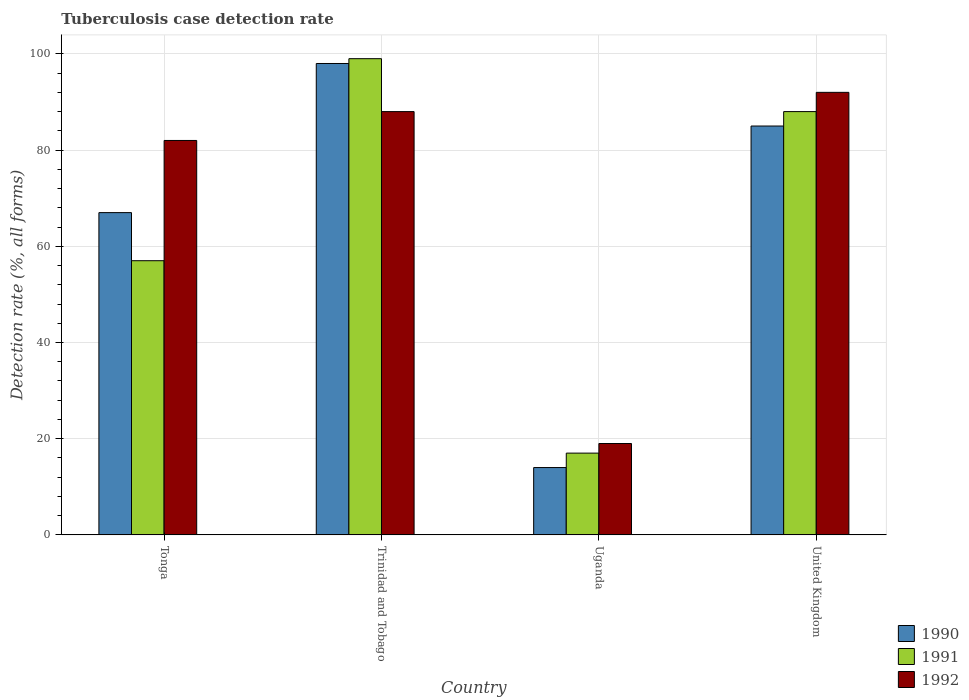How many different coloured bars are there?
Offer a very short reply. 3. Are the number of bars on each tick of the X-axis equal?
Your answer should be compact. Yes. How many bars are there on the 1st tick from the left?
Your answer should be compact. 3. What is the label of the 3rd group of bars from the left?
Offer a very short reply. Uganda. In how many cases, is the number of bars for a given country not equal to the number of legend labels?
Offer a terse response. 0. In which country was the tuberculosis case detection rate in in 1991 maximum?
Give a very brief answer. Trinidad and Tobago. In which country was the tuberculosis case detection rate in in 1991 minimum?
Give a very brief answer. Uganda. What is the total tuberculosis case detection rate in in 1990 in the graph?
Give a very brief answer. 264. What is the difference between the tuberculosis case detection rate in in 1990 in Uganda and that in United Kingdom?
Provide a succinct answer. -71. What is the difference between the tuberculosis case detection rate in in 1992 in Trinidad and Tobago and the tuberculosis case detection rate in in 1991 in Uganda?
Offer a very short reply. 71. What is the average tuberculosis case detection rate in in 1991 per country?
Offer a terse response. 65.25. What is the difference between the tuberculosis case detection rate in of/in 1992 and tuberculosis case detection rate in of/in 1990 in Uganda?
Offer a terse response. 5. What is the ratio of the tuberculosis case detection rate in in 1991 in Tonga to that in Trinidad and Tobago?
Your answer should be very brief. 0.58. Is the tuberculosis case detection rate in in 1991 in Tonga less than that in Trinidad and Tobago?
Provide a succinct answer. Yes. Is the difference between the tuberculosis case detection rate in in 1992 in Uganda and United Kingdom greater than the difference between the tuberculosis case detection rate in in 1990 in Uganda and United Kingdom?
Ensure brevity in your answer.  No. What does the 1st bar from the left in Tonga represents?
Provide a short and direct response. 1990. Is it the case that in every country, the sum of the tuberculosis case detection rate in in 1990 and tuberculosis case detection rate in in 1992 is greater than the tuberculosis case detection rate in in 1991?
Your answer should be compact. Yes. How many bars are there?
Offer a very short reply. 12. Are all the bars in the graph horizontal?
Offer a very short reply. No. Does the graph contain grids?
Your response must be concise. Yes. What is the title of the graph?
Your response must be concise. Tuberculosis case detection rate. What is the label or title of the Y-axis?
Your response must be concise. Detection rate (%, all forms). What is the Detection rate (%, all forms) in 1990 in Tonga?
Make the answer very short. 67. What is the Detection rate (%, all forms) of 1992 in Tonga?
Give a very brief answer. 82. What is the Detection rate (%, all forms) in 1991 in Trinidad and Tobago?
Your answer should be compact. 99. What is the Detection rate (%, all forms) of 1992 in Trinidad and Tobago?
Provide a short and direct response. 88. What is the Detection rate (%, all forms) of 1992 in United Kingdom?
Provide a short and direct response. 92. Across all countries, what is the maximum Detection rate (%, all forms) in 1992?
Your answer should be very brief. 92. What is the total Detection rate (%, all forms) of 1990 in the graph?
Your response must be concise. 264. What is the total Detection rate (%, all forms) in 1991 in the graph?
Make the answer very short. 261. What is the total Detection rate (%, all forms) of 1992 in the graph?
Your answer should be very brief. 281. What is the difference between the Detection rate (%, all forms) in 1990 in Tonga and that in Trinidad and Tobago?
Offer a terse response. -31. What is the difference between the Detection rate (%, all forms) in 1991 in Tonga and that in Trinidad and Tobago?
Provide a short and direct response. -42. What is the difference between the Detection rate (%, all forms) of 1991 in Tonga and that in Uganda?
Your answer should be compact. 40. What is the difference between the Detection rate (%, all forms) in 1990 in Tonga and that in United Kingdom?
Offer a terse response. -18. What is the difference between the Detection rate (%, all forms) of 1991 in Tonga and that in United Kingdom?
Your answer should be compact. -31. What is the difference between the Detection rate (%, all forms) in 1992 in Trinidad and Tobago and that in Uganda?
Make the answer very short. 69. What is the difference between the Detection rate (%, all forms) in 1992 in Trinidad and Tobago and that in United Kingdom?
Your answer should be compact. -4. What is the difference between the Detection rate (%, all forms) of 1990 in Uganda and that in United Kingdom?
Ensure brevity in your answer.  -71. What is the difference between the Detection rate (%, all forms) of 1991 in Uganda and that in United Kingdom?
Your response must be concise. -71. What is the difference between the Detection rate (%, all forms) of 1992 in Uganda and that in United Kingdom?
Make the answer very short. -73. What is the difference between the Detection rate (%, all forms) of 1990 in Tonga and the Detection rate (%, all forms) of 1991 in Trinidad and Tobago?
Give a very brief answer. -32. What is the difference between the Detection rate (%, all forms) in 1990 in Tonga and the Detection rate (%, all forms) in 1992 in Trinidad and Tobago?
Provide a short and direct response. -21. What is the difference between the Detection rate (%, all forms) of 1991 in Tonga and the Detection rate (%, all forms) of 1992 in Trinidad and Tobago?
Your response must be concise. -31. What is the difference between the Detection rate (%, all forms) in 1990 in Tonga and the Detection rate (%, all forms) in 1991 in Uganda?
Ensure brevity in your answer.  50. What is the difference between the Detection rate (%, all forms) of 1990 in Tonga and the Detection rate (%, all forms) of 1992 in Uganda?
Keep it short and to the point. 48. What is the difference between the Detection rate (%, all forms) of 1991 in Tonga and the Detection rate (%, all forms) of 1992 in Uganda?
Make the answer very short. 38. What is the difference between the Detection rate (%, all forms) of 1990 in Tonga and the Detection rate (%, all forms) of 1992 in United Kingdom?
Give a very brief answer. -25. What is the difference between the Detection rate (%, all forms) of 1991 in Tonga and the Detection rate (%, all forms) of 1992 in United Kingdom?
Ensure brevity in your answer.  -35. What is the difference between the Detection rate (%, all forms) of 1990 in Trinidad and Tobago and the Detection rate (%, all forms) of 1992 in Uganda?
Your answer should be very brief. 79. What is the difference between the Detection rate (%, all forms) of 1990 in Trinidad and Tobago and the Detection rate (%, all forms) of 1992 in United Kingdom?
Keep it short and to the point. 6. What is the difference between the Detection rate (%, all forms) of 1990 in Uganda and the Detection rate (%, all forms) of 1991 in United Kingdom?
Keep it short and to the point. -74. What is the difference between the Detection rate (%, all forms) of 1990 in Uganda and the Detection rate (%, all forms) of 1992 in United Kingdom?
Offer a terse response. -78. What is the difference between the Detection rate (%, all forms) of 1991 in Uganda and the Detection rate (%, all forms) of 1992 in United Kingdom?
Your response must be concise. -75. What is the average Detection rate (%, all forms) in 1991 per country?
Make the answer very short. 65.25. What is the average Detection rate (%, all forms) in 1992 per country?
Your answer should be compact. 70.25. What is the difference between the Detection rate (%, all forms) of 1990 and Detection rate (%, all forms) of 1991 in Uganda?
Provide a short and direct response. -3. What is the difference between the Detection rate (%, all forms) in 1991 and Detection rate (%, all forms) in 1992 in Uganda?
Your answer should be compact. -2. What is the difference between the Detection rate (%, all forms) of 1990 and Detection rate (%, all forms) of 1991 in United Kingdom?
Provide a short and direct response. -3. What is the difference between the Detection rate (%, all forms) in 1991 and Detection rate (%, all forms) in 1992 in United Kingdom?
Provide a short and direct response. -4. What is the ratio of the Detection rate (%, all forms) of 1990 in Tonga to that in Trinidad and Tobago?
Ensure brevity in your answer.  0.68. What is the ratio of the Detection rate (%, all forms) of 1991 in Tonga to that in Trinidad and Tobago?
Provide a short and direct response. 0.58. What is the ratio of the Detection rate (%, all forms) in 1992 in Tonga to that in Trinidad and Tobago?
Make the answer very short. 0.93. What is the ratio of the Detection rate (%, all forms) of 1990 in Tonga to that in Uganda?
Make the answer very short. 4.79. What is the ratio of the Detection rate (%, all forms) in 1991 in Tonga to that in Uganda?
Offer a terse response. 3.35. What is the ratio of the Detection rate (%, all forms) of 1992 in Tonga to that in Uganda?
Provide a short and direct response. 4.32. What is the ratio of the Detection rate (%, all forms) in 1990 in Tonga to that in United Kingdom?
Offer a very short reply. 0.79. What is the ratio of the Detection rate (%, all forms) of 1991 in Tonga to that in United Kingdom?
Ensure brevity in your answer.  0.65. What is the ratio of the Detection rate (%, all forms) of 1992 in Tonga to that in United Kingdom?
Provide a short and direct response. 0.89. What is the ratio of the Detection rate (%, all forms) in 1991 in Trinidad and Tobago to that in Uganda?
Offer a terse response. 5.82. What is the ratio of the Detection rate (%, all forms) in 1992 in Trinidad and Tobago to that in Uganda?
Provide a succinct answer. 4.63. What is the ratio of the Detection rate (%, all forms) of 1990 in Trinidad and Tobago to that in United Kingdom?
Ensure brevity in your answer.  1.15. What is the ratio of the Detection rate (%, all forms) in 1991 in Trinidad and Tobago to that in United Kingdom?
Your answer should be very brief. 1.12. What is the ratio of the Detection rate (%, all forms) of 1992 in Trinidad and Tobago to that in United Kingdom?
Your answer should be compact. 0.96. What is the ratio of the Detection rate (%, all forms) of 1990 in Uganda to that in United Kingdom?
Your response must be concise. 0.16. What is the ratio of the Detection rate (%, all forms) of 1991 in Uganda to that in United Kingdom?
Provide a succinct answer. 0.19. What is the ratio of the Detection rate (%, all forms) of 1992 in Uganda to that in United Kingdom?
Provide a succinct answer. 0.21. What is the difference between the highest and the second highest Detection rate (%, all forms) in 1991?
Provide a short and direct response. 11. What is the difference between the highest and the lowest Detection rate (%, all forms) of 1992?
Your response must be concise. 73. 